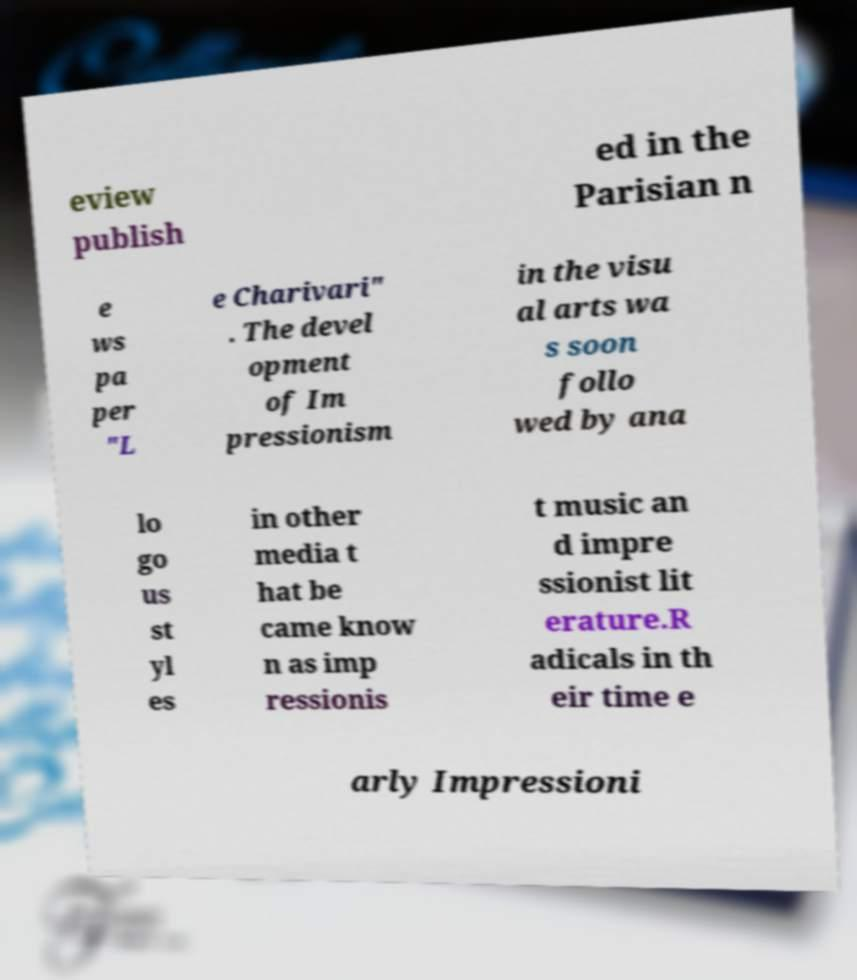Could you assist in decoding the text presented in this image and type it out clearly? eview publish ed in the Parisian n e ws pa per "L e Charivari" . The devel opment of Im pressionism in the visu al arts wa s soon follo wed by ana lo go us st yl es in other media t hat be came know n as imp ressionis t music an d impre ssionist lit erature.R adicals in th eir time e arly Impressioni 